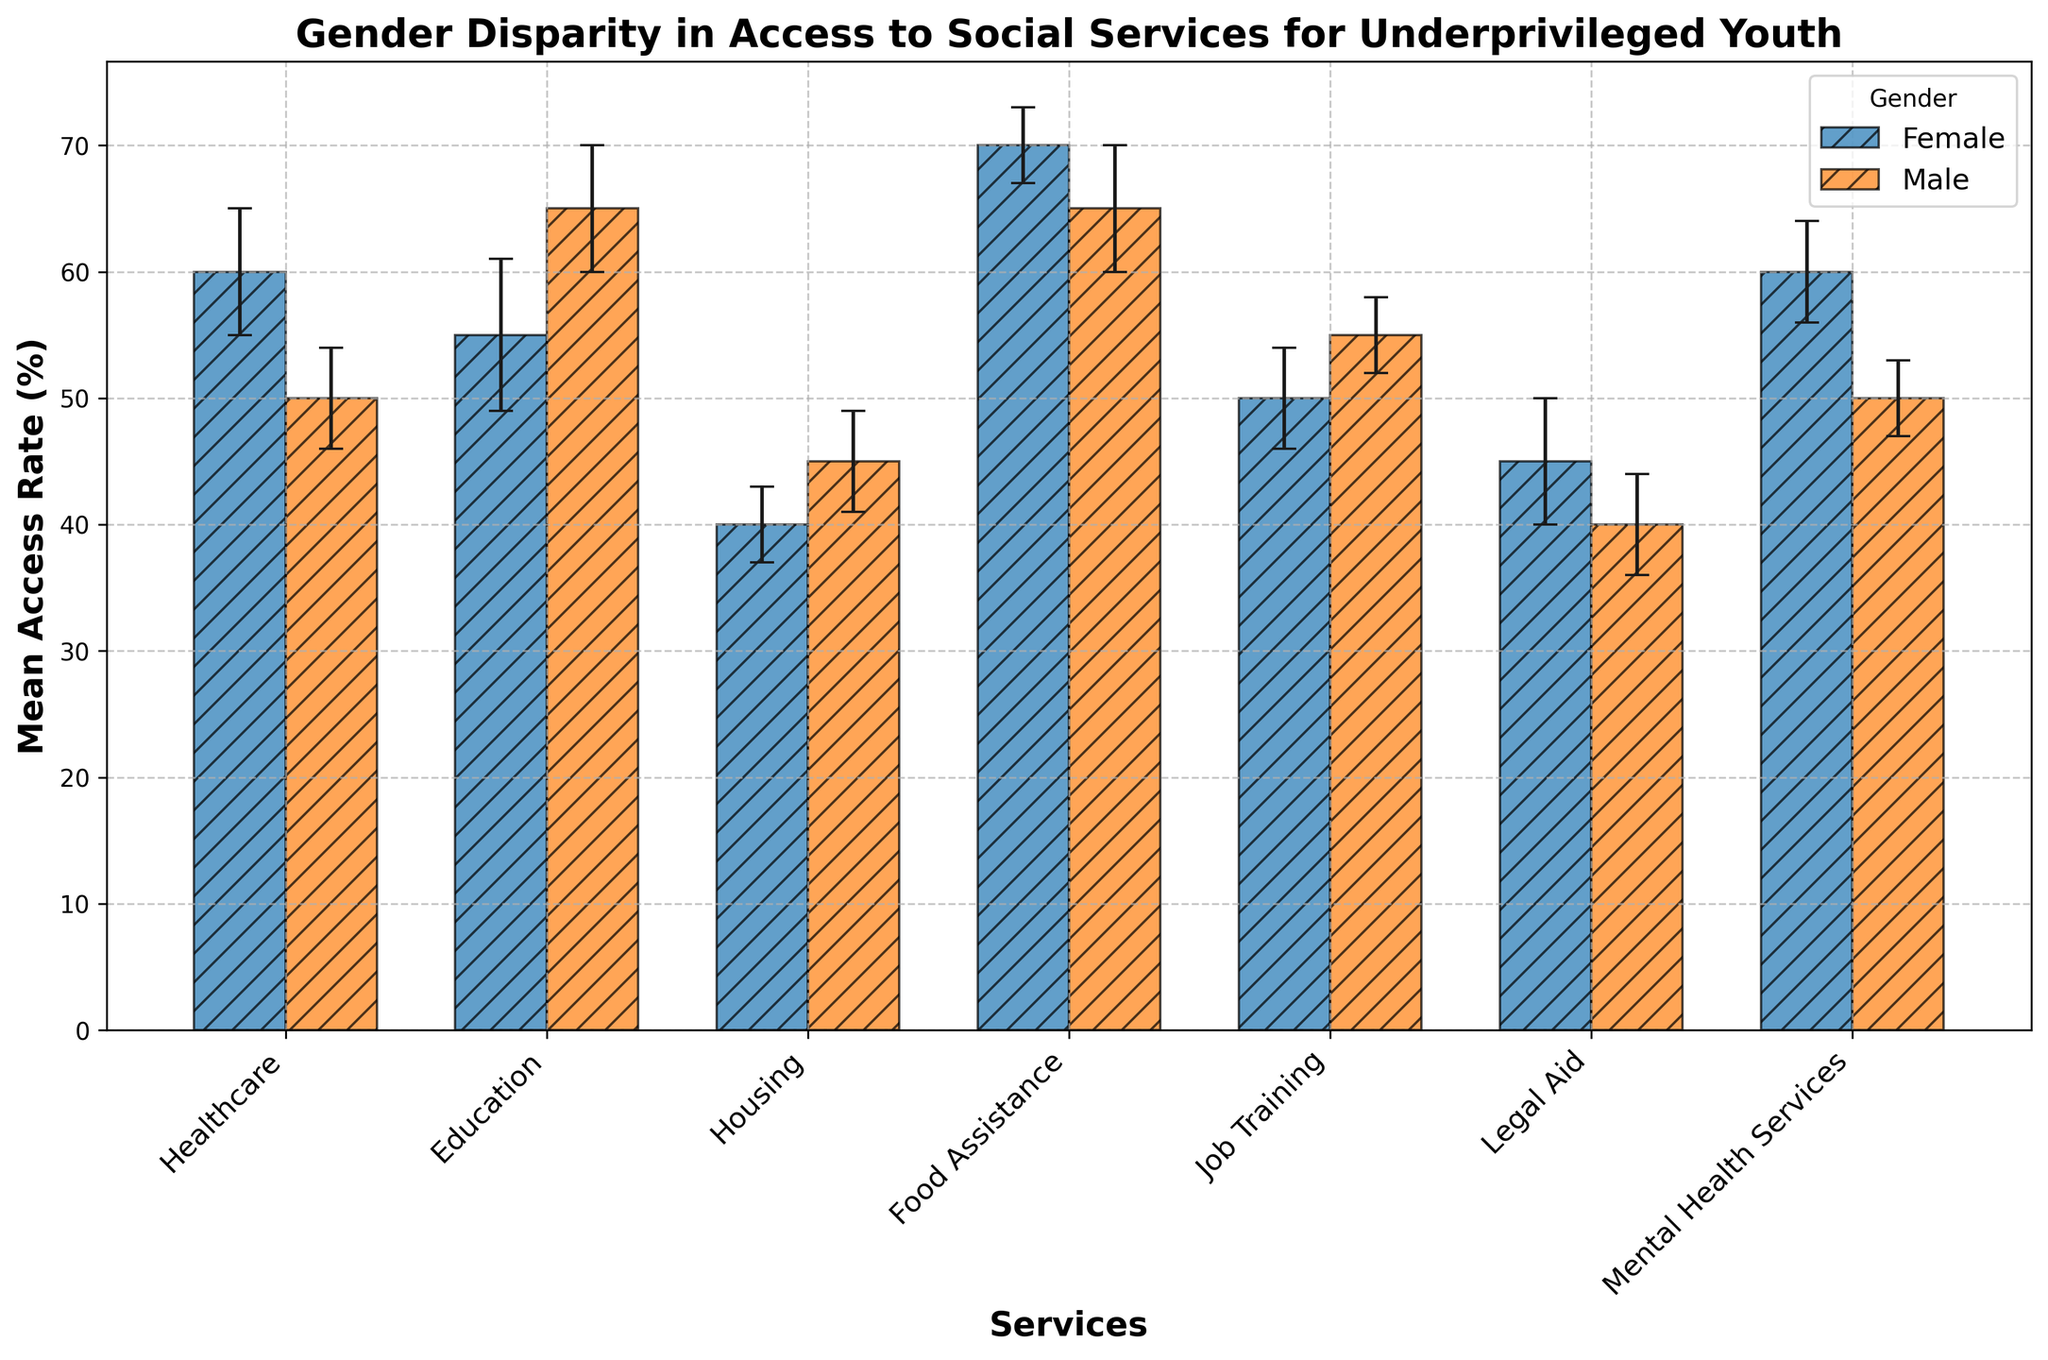What service shows the highest mean access rate for females? By observing the figure, the bar representing Food Assistance for females is the tallest, indicating the highest mean access rate.
Answer: Food Assistance Which gender has a higher mean access rate for Education services? The mean access rates for Education show that the bar for males is taller than the bar for females, indicating a higher mean access rate for males.
Answer: Male What is the difference in mean access rates between males and females for Legal Aid services? The mean access rate for Legal Aid services is 45% for females and 40% for males. The difference is calculated as 45 - 40.
Answer: 5% If you combine the mean access rates for Healthcare and Mental Health Services for females, what is the result? The mean access rate for Healthcare services for females is 60%, and for Mental Health Services, it is 60%. Combining these rates, we have 60 + 60.
Answer: 120% Which service has the largest disparity in mean access rates between males and females? By comparing the differences between the bars for each service, Education services show the largest disparity, with males at 65% and females at 55%, resulting in a 10% difference.
Answer: Education Considering the standard deviations, which service shows the least variability in access rates for males? Observing the error bars for males, Job Training has the shortest error bar indicating the smallest standard deviation of 3.
Answer: Job Training Is the mean access rate for Housing services higher for males or females, and by how much? The mean access rate for Housing services is 45% for males and 40% for females. The rate for males is higher by 45 - 40.
Answer: Males by 5% Which service shows no gender disparity in mean access rates? By observing the bars' height closely, there is no service where both male and female bars are at the same height. Hence, all services show some disparity.
Answer: None What is the average mean access rate for both males and females for Job Training services? The mean access rates for Job Training are 50% for females and 55% for males. Computing the average, we get (50 + 55) / 2.
Answer: 52.5% How do the error bars for Food Assistance services compare between genders? For Food Assistance services, the error bar for females is shorter and represents higher precision (standard deviation is 3), whereas, for males, the error bar is longer (standard deviation is 5).
Answer: Shorter for females 